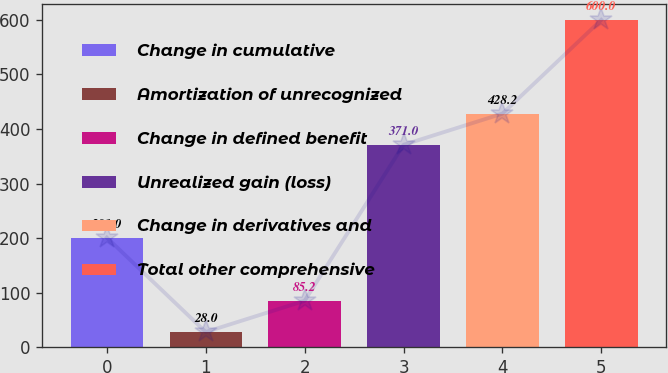Convert chart to OTSL. <chart><loc_0><loc_0><loc_500><loc_500><bar_chart><fcel>Change in cumulative<fcel>Amortization of unrecognized<fcel>Change in defined benefit<fcel>Unrealized gain (loss)<fcel>Change in derivatives and<fcel>Total other comprehensive<nl><fcel>201<fcel>28<fcel>85.2<fcel>371<fcel>428.2<fcel>600<nl></chart> 